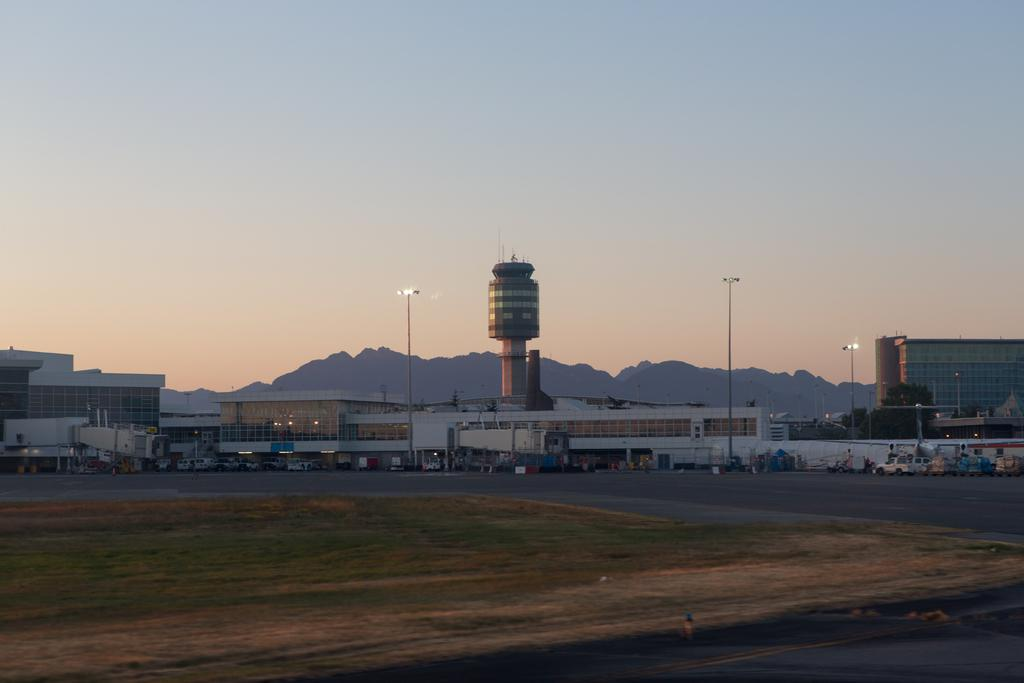What type of structures can be seen in the image? There are buildings in the image. What other objects are present in the image? There are light poles and a building tower in the image. What mode of transportation can be seen in the image? There are vehicles in the image. What natural features can be seen in the background of the image? There are mountains visible in the background of the image. What is visible in the sky in the background of the image? The sky is visible in the background of the image. How long does the sleet last in the image? There is no mention of sleet in the image, so it cannot be determined how long it lasts. What type of meeting is taking place in the image? There is no meeting present in the image. 